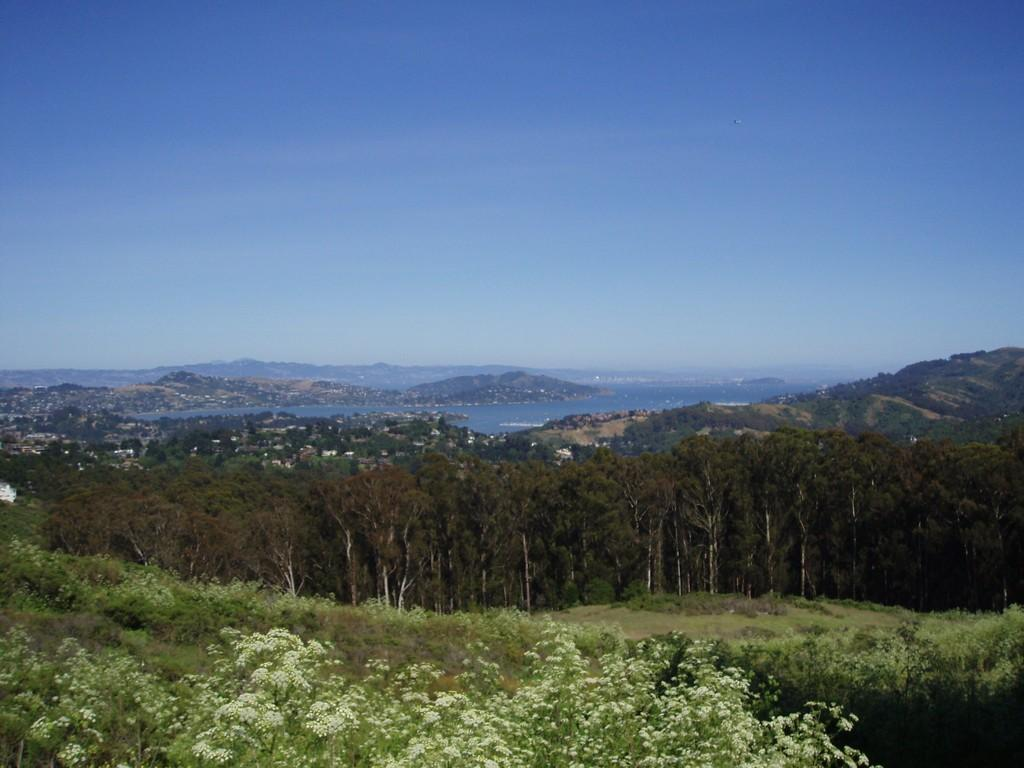What is the main subject of the image? The main subject of the image is the center area, which contains various elements. What can be seen in the sky in the image? The facts provided do not mention any specific details about the sky in the image. What type of landform is present in the center area of the image? There is a hill present in the center area of the image. What type of water feature is present in the center area of the image? There is water present in the center area of the image. What type of vegetation is present in the center area of the image? Trees, plants, grass, and flowers are present in the center area of the image. What type of hearing aid is visible on the hill in the image? There is no hearing aid visible on the hill in the image. What type of middle school can be seen in the image? There is no middle school present in the image. 